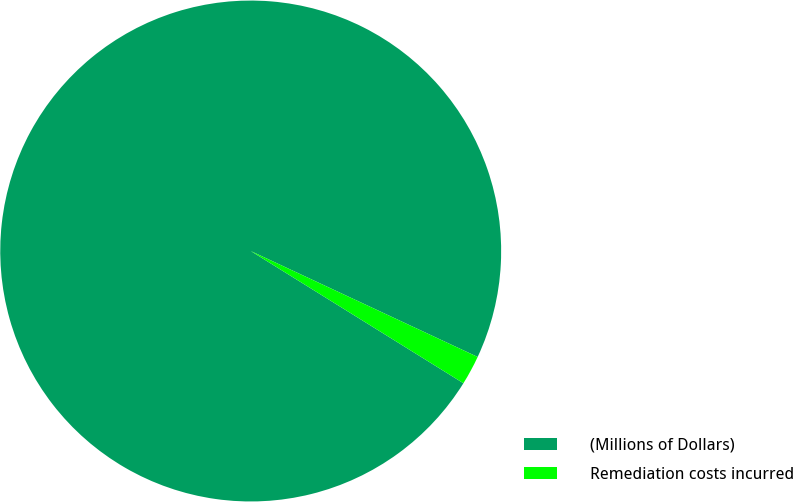Convert chart to OTSL. <chart><loc_0><loc_0><loc_500><loc_500><pie_chart><fcel>(Millions of Dollars)<fcel>Remediation costs incurred<nl><fcel>98.1%<fcel>1.9%<nl></chart> 